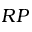Convert formula to latex. <formula><loc_0><loc_0><loc_500><loc_500>R P</formula> 